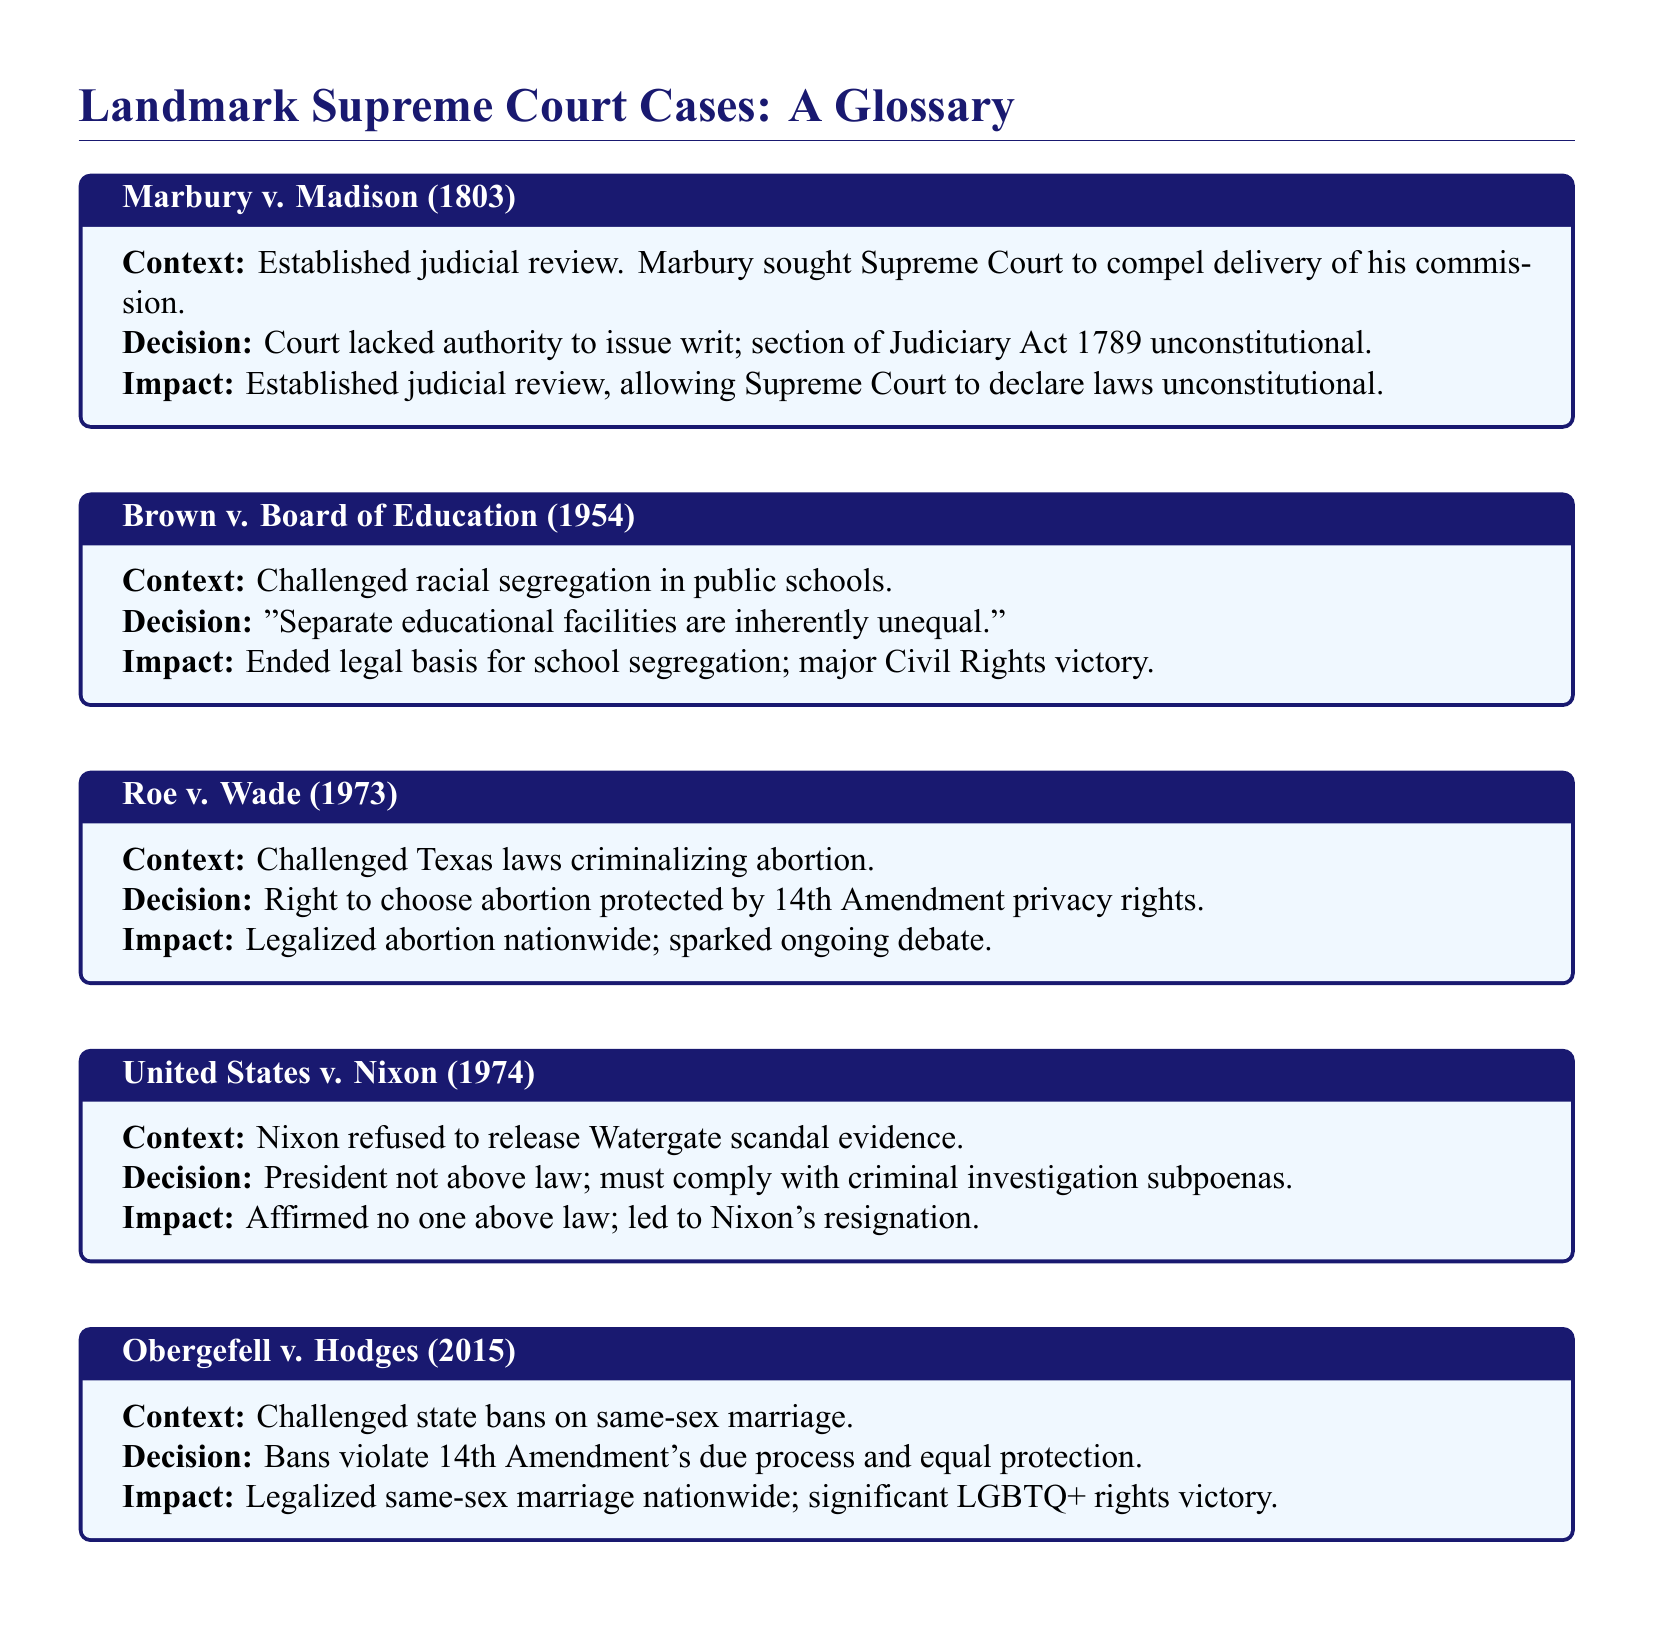What is the significance of Marbury v. Madison? Marbury v. Madison established the principle of judicial review, allowing the Supreme Court to declare laws unconstitutional.
Answer: Judicial review In which year was Roe v. Wade decided? Roe v. Wade was decided in 1973, as stated in the document.
Answer: 1973 What did the Court decide in Brown v. Board of Education? The decision stated that "Separate educational facilities are inherently unequal."
Answer: Inherently unequal What major impact did United States v. Nixon have? United States v. Nixon affirmed that no one is above the law, leading to Nixon's resignation.
Answer: Nixon's resignation Which amendment was cited in Obergefell v. Hodges? The 14th Amendment was cited, specifically its due process and equal protection clauses.
Answer: 14th Amendment What case challenged state bans on same-sex marriage? The case that challenged state bans on same-sex marriage is Obergefell v. Hodges.
Answer: Obergefell v. Hodges What legal basis did Brown v. Board of Education end? Brown v. Board of Education ended the legal basis for school segregation.
Answer: School segregation What was the context of United States v. Nixon? The context involved Nixon's refusal to release evidence related to the Watergate scandal.
Answer: Watergate scandal Which Supreme Court case addressed abortion rights? Roe v. Wade addressed abortion rights, challenging laws that criminalized abortion.
Answer: Roe v. Wade 